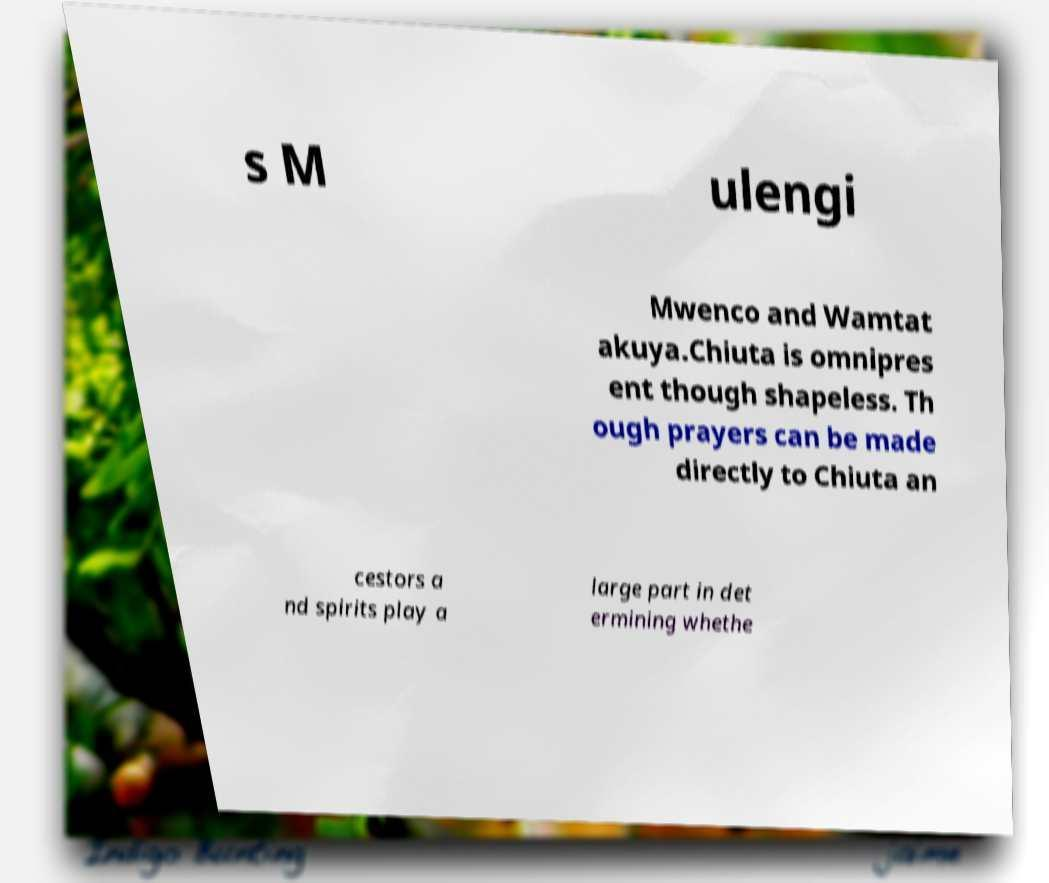For documentation purposes, I need the text within this image transcribed. Could you provide that? s M ulengi Mwenco and Wamtat akuya.Chiuta is omnipres ent though shapeless. Th ough prayers can be made directly to Chiuta an cestors a nd spirits play a large part in det ermining whethe 